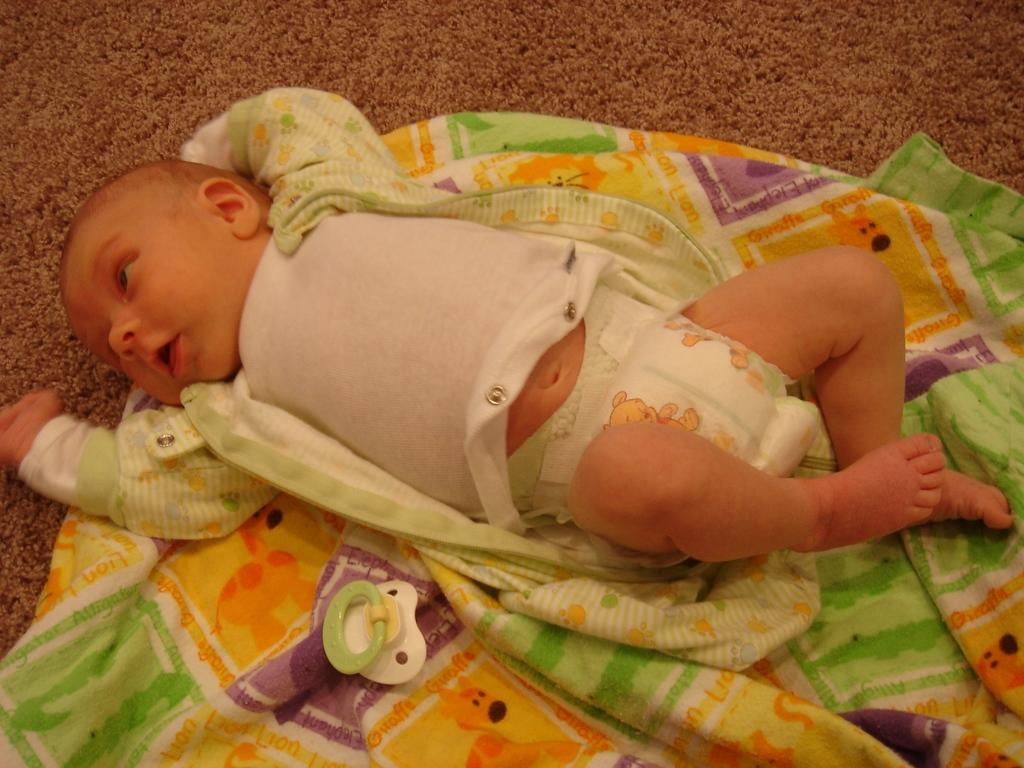What is the main subject of the image? There is a baby in the center of the image. What is the baby doing in the image? The baby is sleeping on a blanket. Are there any objects or toys in the image? Yes, there is a toy in the image. How does the crowd react to the baby's wish in the image? There is no crowd or wish present in the image; it only features a baby sleeping on a blanket and a toy. 